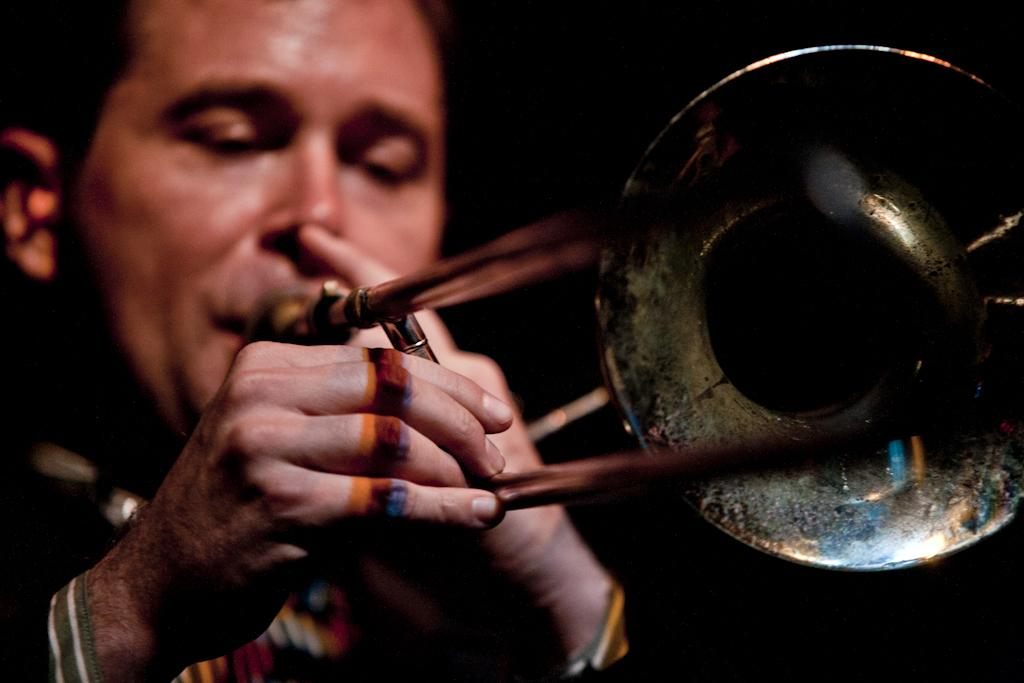What is the man in the image doing? The man is playing the trumpet. What can be seen in the background of the image? The background of the image appears dark. What type of powder is being used by the man's brother in the image? There is no mention of a brother or powder in the image, so it cannot be determined from the image. 